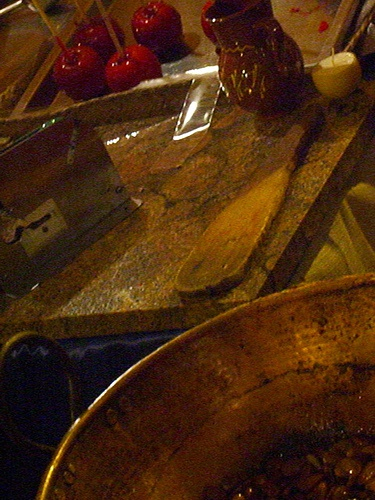Describe the objects in this image and their specific colors. I can see dining table in navy, black, maroon, and olive tones, bowl in navy, black, maroon, and brown tones, spoon in navy, olive, maroon, and black tones, cup in navy, black, maroon, and olive tones, and apple in navy, maroon, black, and brown tones in this image. 